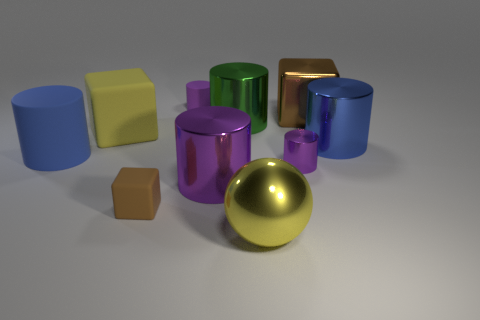Subtract all gray balls. How many purple cylinders are left? 3 Subtract 3 cylinders. How many cylinders are left? 3 Subtract all blue cylinders. How many cylinders are left? 4 Subtract all purple metallic cylinders. How many cylinders are left? 4 Subtract all green cylinders. Subtract all gray blocks. How many cylinders are left? 5 Subtract all cubes. How many objects are left? 7 Add 7 small brown matte things. How many small brown matte things exist? 8 Subtract 0 brown cylinders. How many objects are left? 10 Subtract all tiny things. Subtract all tiny rubber cubes. How many objects are left? 6 Add 3 large metallic blocks. How many large metallic blocks are left? 4 